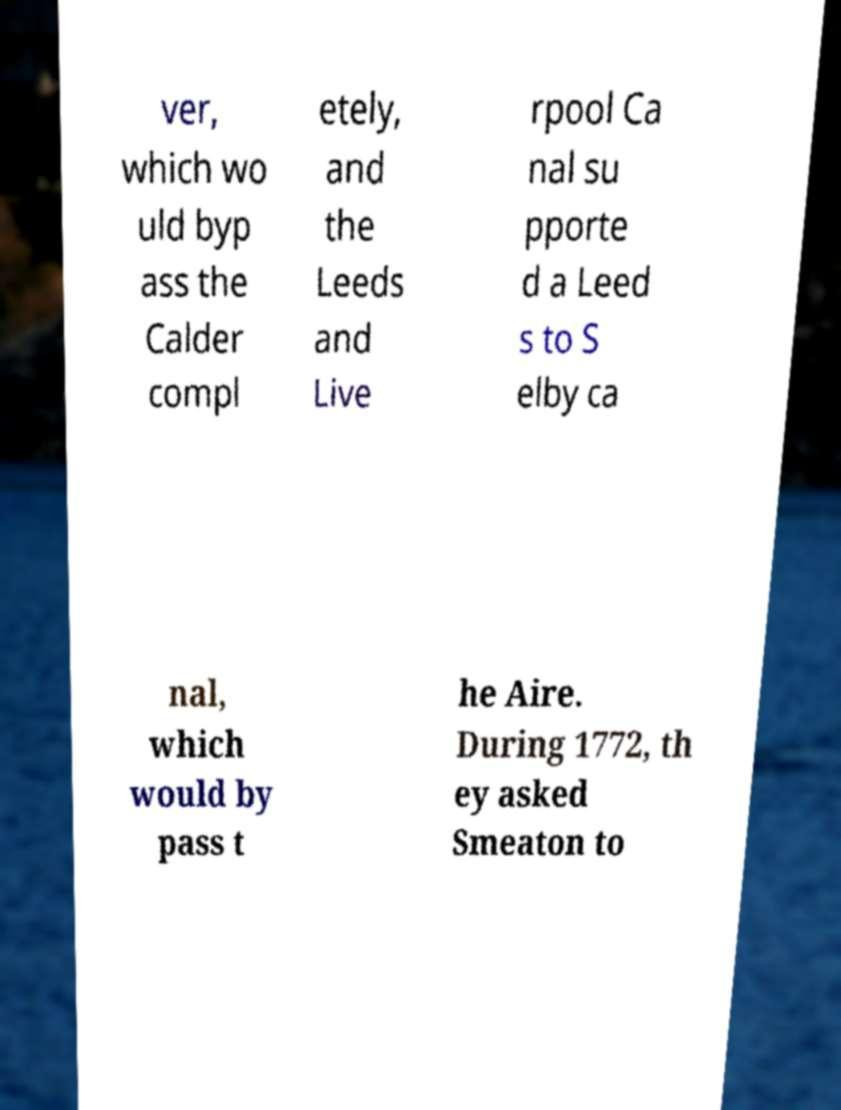For documentation purposes, I need the text within this image transcribed. Could you provide that? ver, which wo uld byp ass the Calder compl etely, and the Leeds and Live rpool Ca nal su pporte d a Leed s to S elby ca nal, which would by pass t he Aire. During 1772, th ey asked Smeaton to 